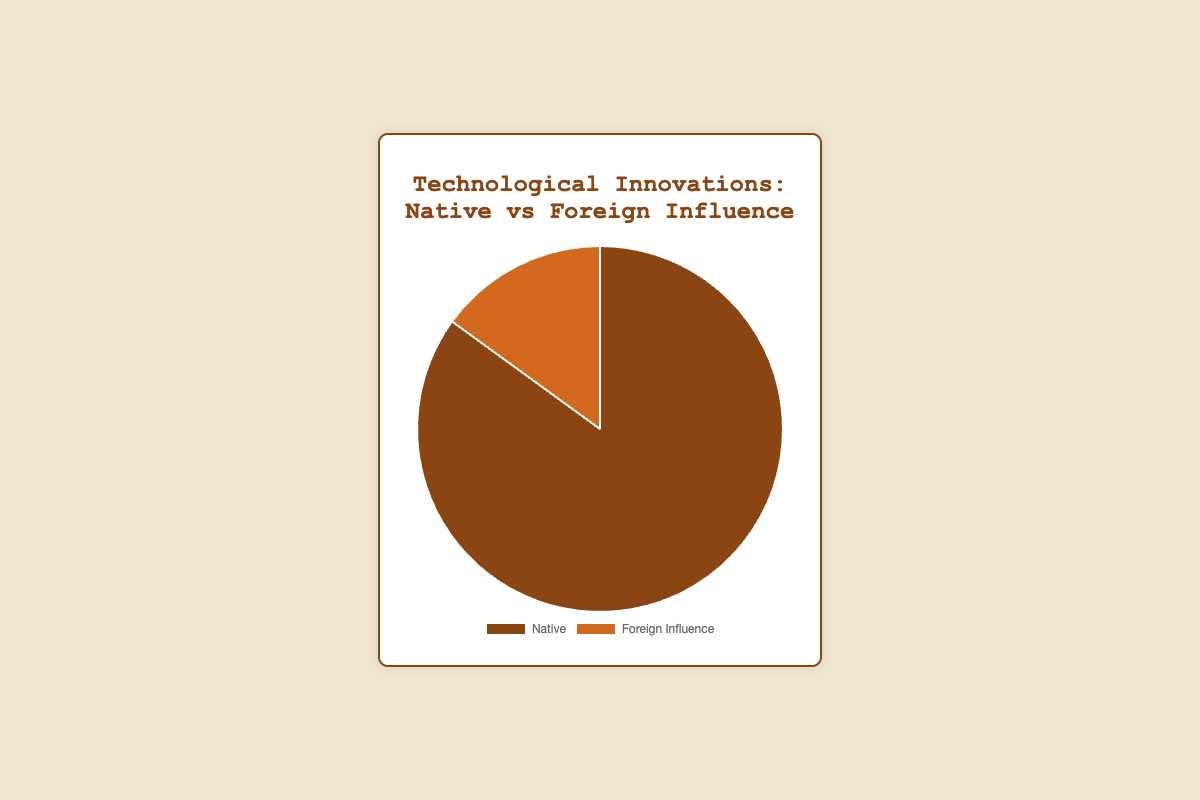Which source accounts for a higher proportion of technological innovations, native or foreign influence? The pie chart shows two categories: Native and Foreign Influence. The segment labeled "Native" visually appears larger than the segment labeled "Foreign Influence". According to the chart, Native influence accounts for 85%, which is higher than Foreign Influence at 15%.
Answer: Native What is the combined proportion of technological innovations attributed to the United States? From the pie chart, we know that the innovations attributed to the United States (Telegraph, Light Bulb, and Internet) account for 15% + 10% + 10% respectively. Adding these proportions, we get 15 + 10 + 10 = 35%.
Answer: 35% Which segment is larger, those innovations attributed to the United States or those influenced by foreign countries? Looking at the proportions, the United States has 15% (Telegraph) + 10% (Light Bulb) + 10% (Internet) = 35%, while Foreign Influence totals 15%. Since 35% > 15%, the segment attributed to the United States is larger.
Answer: United States How does the proportion of innovations attributed to Germany compare between native and foreign influences? For native influence, Germany is attributed to the Automobile with 15%. For foreign influence, Germany is attributed to Nuclear Power with 5%. Comparing 15% (native) to 5% (foreign influence), Germany has a larger proportion of innovations attributed to native influences.
Answer: Native What percentage of the total innovations are ascribed to smaller proportions (5%) categories? The given data indicates three technological innovations categorized under 5% each (Nuclear Power, Penicillin, Electric Motor). Summing these up, 5% + 5% + 5% = 15%.
Answer: 15% Are there more innovations attributed to the United Kingdom or to Canada? The United Kingdom has two entries: Steam Engine at 25% and Penicillin at 5%, totaling 30%. Canada has the Telephone at 10%. Therefore, the UK has more innovations attributed to it than Canada, as 30% is greater than 10%.
Answer: United Kingdom What proportion of innovations attributed to a single country constitutes the largest slice of the pie chart? The individual proportions listed include the Steam Engine (25% from the UK), which is the largest single proportion attributed to any country.
Answer: 25% Is there any color visual indication used to distinguish between native and foreign influences? Yes, the segments in the pie chart have different colors to differentiate them. The "Native" category is shown with a brown color, while "Foreign Influence" is shown with an orange color.
Answer: Yes 